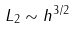<formula> <loc_0><loc_0><loc_500><loc_500>L _ { 2 } \sim h ^ { 3 / 2 }</formula> 